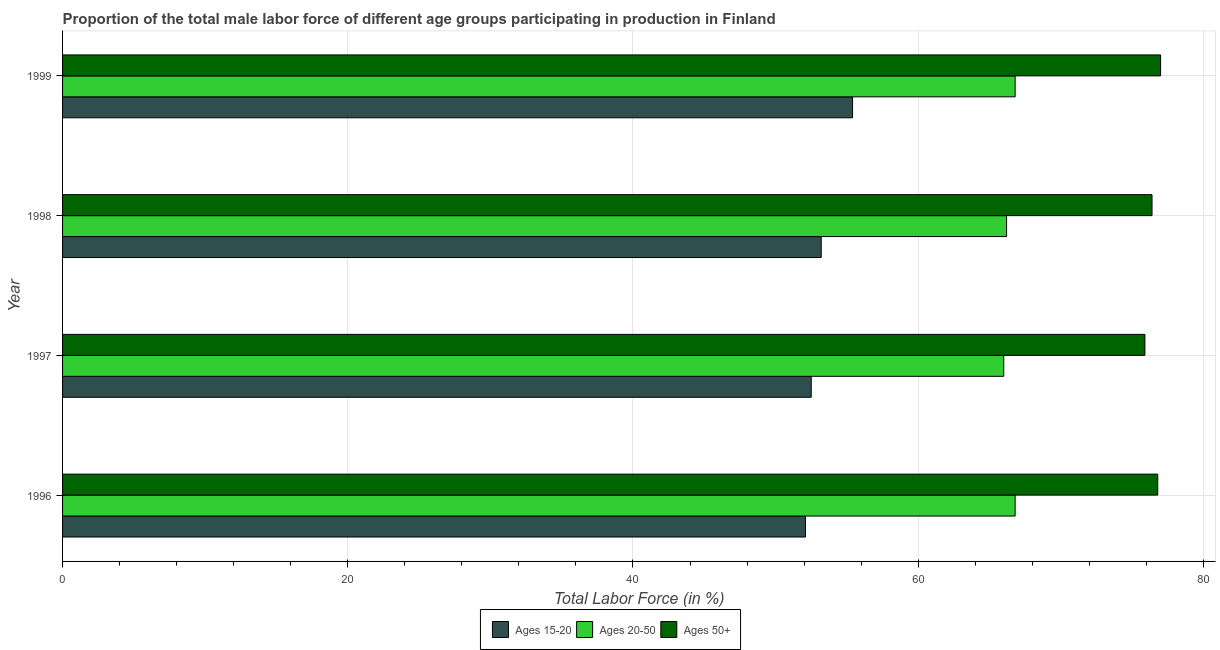How many different coloured bars are there?
Ensure brevity in your answer.  3. Are the number of bars on each tick of the Y-axis equal?
Offer a very short reply. Yes. How many bars are there on the 2nd tick from the bottom?
Make the answer very short. 3. What is the label of the 2nd group of bars from the top?
Provide a short and direct response. 1998. In how many cases, is the number of bars for a given year not equal to the number of legend labels?
Your response must be concise. 0. What is the percentage of male labor force within the age group 15-20 in 1999?
Your answer should be very brief. 55.4. Across all years, what is the maximum percentage of male labor force above age 50?
Ensure brevity in your answer.  77. Across all years, what is the minimum percentage of male labor force within the age group 15-20?
Ensure brevity in your answer.  52.1. In which year was the percentage of male labor force within the age group 15-20 maximum?
Offer a terse response. 1999. What is the total percentage of male labor force within the age group 20-50 in the graph?
Provide a succinct answer. 265.8. What is the difference between the percentage of male labor force within the age group 15-20 in 1996 and the percentage of male labor force above age 50 in 1998?
Give a very brief answer. -24.3. What is the average percentage of male labor force within the age group 20-50 per year?
Provide a short and direct response. 66.45. In the year 1997, what is the difference between the percentage of male labor force above age 50 and percentage of male labor force within the age group 15-20?
Your answer should be compact. 23.4. In how many years, is the percentage of male labor force within the age group 20-50 greater than 40 %?
Your answer should be compact. 4. What is the ratio of the percentage of male labor force within the age group 15-20 in 1997 to that in 1998?
Provide a short and direct response. 0.99. Is the percentage of male labor force above age 50 in 1996 less than that in 1998?
Provide a short and direct response. No. In how many years, is the percentage of male labor force within the age group 20-50 greater than the average percentage of male labor force within the age group 20-50 taken over all years?
Your response must be concise. 2. Is the sum of the percentage of male labor force within the age group 20-50 in 1996 and 1997 greater than the maximum percentage of male labor force within the age group 15-20 across all years?
Make the answer very short. Yes. What does the 1st bar from the top in 1999 represents?
Ensure brevity in your answer.  Ages 50+. What does the 2nd bar from the bottom in 1998 represents?
Your response must be concise. Ages 20-50. Is it the case that in every year, the sum of the percentage of male labor force within the age group 15-20 and percentage of male labor force within the age group 20-50 is greater than the percentage of male labor force above age 50?
Provide a short and direct response. Yes. How many bars are there?
Keep it short and to the point. 12. How many years are there in the graph?
Provide a succinct answer. 4. Are the values on the major ticks of X-axis written in scientific E-notation?
Keep it short and to the point. No. Does the graph contain any zero values?
Give a very brief answer. No. What is the title of the graph?
Make the answer very short. Proportion of the total male labor force of different age groups participating in production in Finland. What is the Total Labor Force (in %) in Ages 15-20 in 1996?
Give a very brief answer. 52.1. What is the Total Labor Force (in %) of Ages 20-50 in 1996?
Provide a short and direct response. 66.8. What is the Total Labor Force (in %) of Ages 50+ in 1996?
Your answer should be compact. 76.8. What is the Total Labor Force (in %) of Ages 15-20 in 1997?
Provide a succinct answer. 52.5. What is the Total Labor Force (in %) of Ages 20-50 in 1997?
Make the answer very short. 66. What is the Total Labor Force (in %) in Ages 50+ in 1997?
Offer a very short reply. 75.9. What is the Total Labor Force (in %) of Ages 15-20 in 1998?
Your response must be concise. 53.2. What is the Total Labor Force (in %) of Ages 20-50 in 1998?
Your response must be concise. 66.2. What is the Total Labor Force (in %) of Ages 50+ in 1998?
Your answer should be very brief. 76.4. What is the Total Labor Force (in %) of Ages 15-20 in 1999?
Your answer should be very brief. 55.4. What is the Total Labor Force (in %) of Ages 20-50 in 1999?
Make the answer very short. 66.8. What is the Total Labor Force (in %) of Ages 50+ in 1999?
Your answer should be compact. 77. Across all years, what is the maximum Total Labor Force (in %) in Ages 15-20?
Provide a succinct answer. 55.4. Across all years, what is the maximum Total Labor Force (in %) in Ages 20-50?
Your response must be concise. 66.8. Across all years, what is the minimum Total Labor Force (in %) of Ages 15-20?
Provide a succinct answer. 52.1. Across all years, what is the minimum Total Labor Force (in %) in Ages 20-50?
Offer a very short reply. 66. Across all years, what is the minimum Total Labor Force (in %) of Ages 50+?
Your answer should be very brief. 75.9. What is the total Total Labor Force (in %) of Ages 15-20 in the graph?
Your response must be concise. 213.2. What is the total Total Labor Force (in %) in Ages 20-50 in the graph?
Offer a terse response. 265.8. What is the total Total Labor Force (in %) in Ages 50+ in the graph?
Provide a short and direct response. 306.1. What is the difference between the Total Labor Force (in %) in Ages 20-50 in 1996 and that in 1997?
Keep it short and to the point. 0.8. What is the difference between the Total Labor Force (in %) of Ages 50+ in 1996 and that in 1997?
Your response must be concise. 0.9. What is the difference between the Total Labor Force (in %) of Ages 20-50 in 1996 and that in 1998?
Make the answer very short. 0.6. What is the difference between the Total Labor Force (in %) of Ages 50+ in 1996 and that in 1998?
Give a very brief answer. 0.4. What is the difference between the Total Labor Force (in %) of Ages 15-20 in 1996 and that in 1999?
Offer a very short reply. -3.3. What is the difference between the Total Labor Force (in %) in Ages 20-50 in 1996 and that in 1999?
Your answer should be very brief. 0. What is the difference between the Total Labor Force (in %) in Ages 50+ in 1996 and that in 1999?
Provide a succinct answer. -0.2. What is the difference between the Total Labor Force (in %) in Ages 20-50 in 1997 and that in 1998?
Provide a succinct answer. -0.2. What is the difference between the Total Labor Force (in %) in Ages 15-20 in 1997 and that in 1999?
Provide a succinct answer. -2.9. What is the difference between the Total Labor Force (in %) in Ages 20-50 in 1997 and that in 1999?
Keep it short and to the point. -0.8. What is the difference between the Total Labor Force (in %) in Ages 20-50 in 1998 and that in 1999?
Offer a very short reply. -0.6. What is the difference between the Total Labor Force (in %) of Ages 15-20 in 1996 and the Total Labor Force (in %) of Ages 20-50 in 1997?
Keep it short and to the point. -13.9. What is the difference between the Total Labor Force (in %) in Ages 15-20 in 1996 and the Total Labor Force (in %) in Ages 50+ in 1997?
Keep it short and to the point. -23.8. What is the difference between the Total Labor Force (in %) in Ages 20-50 in 1996 and the Total Labor Force (in %) in Ages 50+ in 1997?
Offer a very short reply. -9.1. What is the difference between the Total Labor Force (in %) of Ages 15-20 in 1996 and the Total Labor Force (in %) of Ages 20-50 in 1998?
Offer a very short reply. -14.1. What is the difference between the Total Labor Force (in %) in Ages 15-20 in 1996 and the Total Labor Force (in %) in Ages 50+ in 1998?
Your answer should be very brief. -24.3. What is the difference between the Total Labor Force (in %) in Ages 15-20 in 1996 and the Total Labor Force (in %) in Ages 20-50 in 1999?
Keep it short and to the point. -14.7. What is the difference between the Total Labor Force (in %) in Ages 15-20 in 1996 and the Total Labor Force (in %) in Ages 50+ in 1999?
Provide a succinct answer. -24.9. What is the difference between the Total Labor Force (in %) in Ages 15-20 in 1997 and the Total Labor Force (in %) in Ages 20-50 in 1998?
Keep it short and to the point. -13.7. What is the difference between the Total Labor Force (in %) of Ages 15-20 in 1997 and the Total Labor Force (in %) of Ages 50+ in 1998?
Offer a very short reply. -23.9. What is the difference between the Total Labor Force (in %) in Ages 15-20 in 1997 and the Total Labor Force (in %) in Ages 20-50 in 1999?
Provide a succinct answer. -14.3. What is the difference between the Total Labor Force (in %) of Ages 15-20 in 1997 and the Total Labor Force (in %) of Ages 50+ in 1999?
Offer a terse response. -24.5. What is the difference between the Total Labor Force (in %) in Ages 15-20 in 1998 and the Total Labor Force (in %) in Ages 20-50 in 1999?
Provide a succinct answer. -13.6. What is the difference between the Total Labor Force (in %) in Ages 15-20 in 1998 and the Total Labor Force (in %) in Ages 50+ in 1999?
Offer a terse response. -23.8. What is the average Total Labor Force (in %) in Ages 15-20 per year?
Make the answer very short. 53.3. What is the average Total Labor Force (in %) of Ages 20-50 per year?
Your answer should be compact. 66.45. What is the average Total Labor Force (in %) of Ages 50+ per year?
Your answer should be very brief. 76.53. In the year 1996, what is the difference between the Total Labor Force (in %) in Ages 15-20 and Total Labor Force (in %) in Ages 20-50?
Ensure brevity in your answer.  -14.7. In the year 1996, what is the difference between the Total Labor Force (in %) of Ages 15-20 and Total Labor Force (in %) of Ages 50+?
Provide a short and direct response. -24.7. In the year 1997, what is the difference between the Total Labor Force (in %) of Ages 15-20 and Total Labor Force (in %) of Ages 50+?
Give a very brief answer. -23.4. In the year 1998, what is the difference between the Total Labor Force (in %) in Ages 15-20 and Total Labor Force (in %) in Ages 20-50?
Offer a very short reply. -13. In the year 1998, what is the difference between the Total Labor Force (in %) in Ages 15-20 and Total Labor Force (in %) in Ages 50+?
Make the answer very short. -23.2. In the year 1998, what is the difference between the Total Labor Force (in %) in Ages 20-50 and Total Labor Force (in %) in Ages 50+?
Your answer should be compact. -10.2. In the year 1999, what is the difference between the Total Labor Force (in %) of Ages 15-20 and Total Labor Force (in %) of Ages 20-50?
Your answer should be compact. -11.4. In the year 1999, what is the difference between the Total Labor Force (in %) of Ages 15-20 and Total Labor Force (in %) of Ages 50+?
Offer a terse response. -21.6. In the year 1999, what is the difference between the Total Labor Force (in %) in Ages 20-50 and Total Labor Force (in %) in Ages 50+?
Give a very brief answer. -10.2. What is the ratio of the Total Labor Force (in %) of Ages 20-50 in 1996 to that in 1997?
Your answer should be compact. 1.01. What is the ratio of the Total Labor Force (in %) in Ages 50+ in 1996 to that in 1997?
Your response must be concise. 1.01. What is the ratio of the Total Labor Force (in %) of Ages 15-20 in 1996 to that in 1998?
Ensure brevity in your answer.  0.98. What is the ratio of the Total Labor Force (in %) of Ages 20-50 in 1996 to that in 1998?
Offer a terse response. 1.01. What is the ratio of the Total Labor Force (in %) of Ages 15-20 in 1996 to that in 1999?
Provide a succinct answer. 0.94. What is the ratio of the Total Labor Force (in %) of Ages 15-20 in 1997 to that in 1998?
Offer a terse response. 0.99. What is the ratio of the Total Labor Force (in %) of Ages 15-20 in 1997 to that in 1999?
Ensure brevity in your answer.  0.95. What is the ratio of the Total Labor Force (in %) of Ages 20-50 in 1997 to that in 1999?
Give a very brief answer. 0.99. What is the ratio of the Total Labor Force (in %) in Ages 50+ in 1997 to that in 1999?
Give a very brief answer. 0.99. What is the ratio of the Total Labor Force (in %) of Ages 15-20 in 1998 to that in 1999?
Offer a very short reply. 0.96. What is the ratio of the Total Labor Force (in %) in Ages 50+ in 1998 to that in 1999?
Provide a short and direct response. 0.99. What is the difference between the highest and the second highest Total Labor Force (in %) of Ages 20-50?
Your answer should be very brief. 0. What is the difference between the highest and the second highest Total Labor Force (in %) in Ages 50+?
Ensure brevity in your answer.  0.2. What is the difference between the highest and the lowest Total Labor Force (in %) in Ages 15-20?
Offer a terse response. 3.3. What is the difference between the highest and the lowest Total Labor Force (in %) in Ages 20-50?
Your answer should be compact. 0.8. What is the difference between the highest and the lowest Total Labor Force (in %) of Ages 50+?
Make the answer very short. 1.1. 